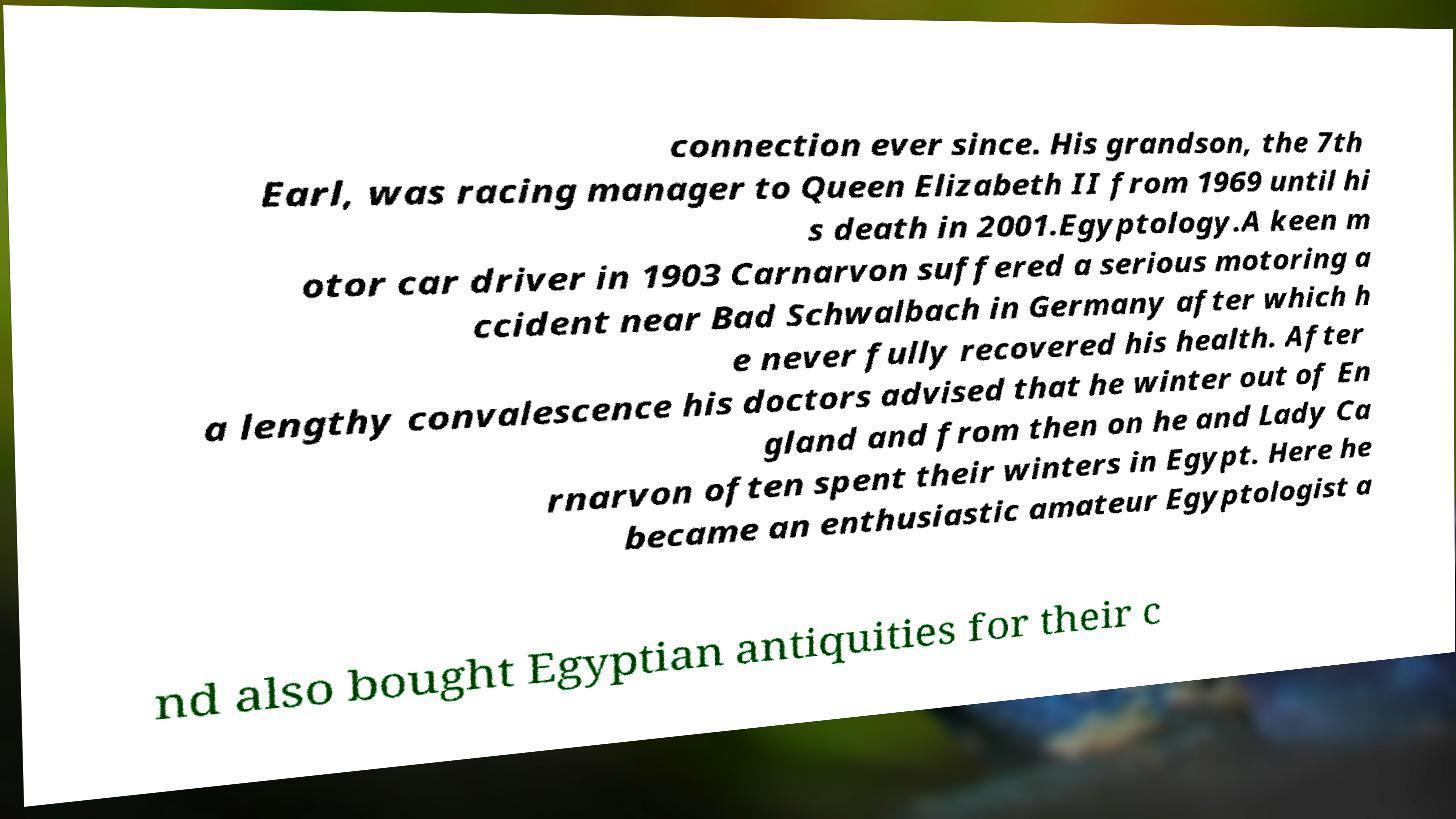I need the written content from this picture converted into text. Can you do that? connection ever since. His grandson, the 7th Earl, was racing manager to Queen Elizabeth II from 1969 until hi s death in 2001.Egyptology.A keen m otor car driver in 1903 Carnarvon suffered a serious motoring a ccident near Bad Schwalbach in Germany after which h e never fully recovered his health. After a lengthy convalescence his doctors advised that he winter out of En gland and from then on he and Lady Ca rnarvon often spent their winters in Egypt. Here he became an enthusiastic amateur Egyptologist a nd also bought Egyptian antiquities for their c 